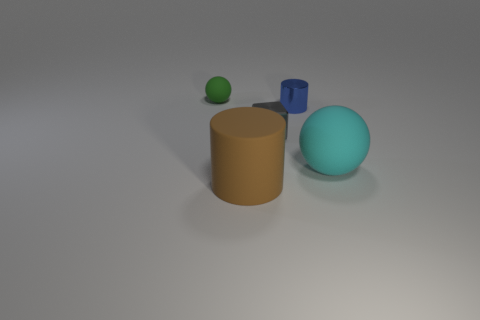Add 1 big brown cylinders. How many objects exist? 6 Subtract all blocks. How many objects are left? 4 Add 3 small blue shiny objects. How many small blue shiny objects exist? 4 Subtract 0 cyan cylinders. How many objects are left? 5 Subtract all gray metallic blocks. Subtract all tiny green rubber cylinders. How many objects are left? 4 Add 5 shiny objects. How many shiny objects are left? 7 